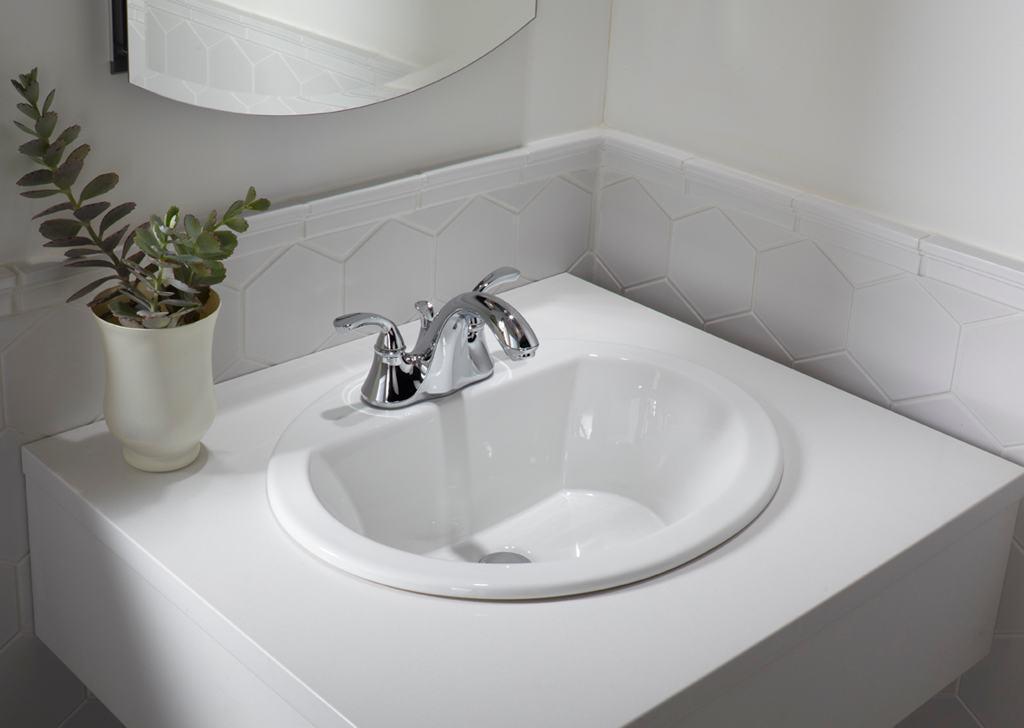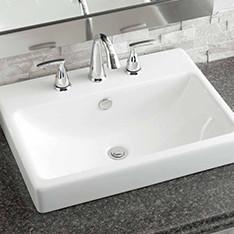The first image is the image on the left, the second image is the image on the right. For the images displayed, is the sentence "there is a towel in the image on the left." factually correct? Answer yes or no. No. The first image is the image on the left, the second image is the image on the right. Given the left and right images, does the statement "Both images feature a single-sink vanity." hold true? Answer yes or no. Yes. 